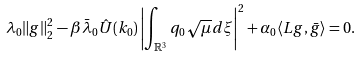Convert formula to latex. <formula><loc_0><loc_0><loc_500><loc_500>\lambda _ { 0 } \| g \| _ { 2 } ^ { 2 } - \beta \bar { \lambda } _ { 0 } \hat { U } ( k _ { 0 } ) \left | \int _ { \mathbb { R } ^ { 3 } } q _ { 0 } \sqrt { \mu } d \xi \right | ^ { 2 } + \alpha _ { 0 } \langle L g , \bar { g } \rangle = 0 .</formula> 